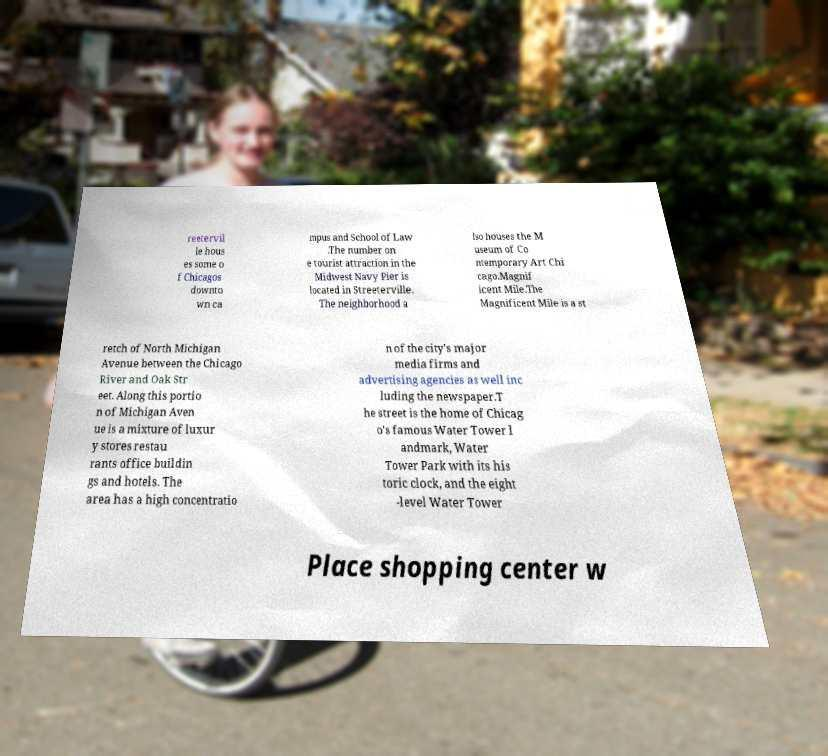Could you extract and type out the text from this image? reetervil le hous es some o f Chicagos downto wn ca mpus and School of Law .The number on e tourist attraction in the Midwest Navy Pier is located in Streeterville. The neighborhood a lso houses the M useum of Co ntemporary Art Chi cago.Magnif icent Mile.The Magnificent Mile is a st retch of North Michigan Avenue between the Chicago River and Oak Str eet. Along this portio n of Michigan Aven ue is a mixture of luxur y stores restau rants office buildin gs and hotels. The area has a high concentratio n of the city's major media firms and advertising agencies as well inc luding the newspaper.T he street is the home of Chicag o's famous Water Tower l andmark, Water Tower Park with its his toric clock, and the eight -level Water Tower Place shopping center w 